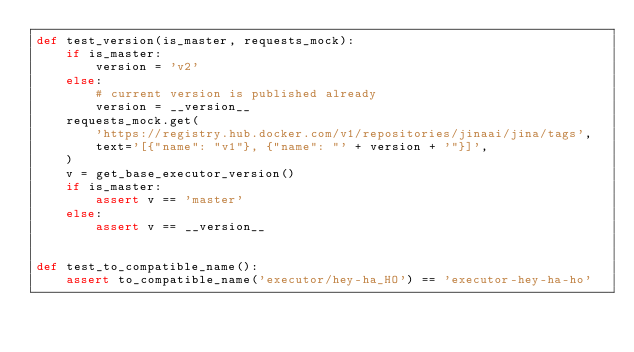Convert code to text. <code><loc_0><loc_0><loc_500><loc_500><_Python_>def test_version(is_master, requests_mock):
    if is_master:
        version = 'v2'
    else:
        # current version is published already
        version = __version__
    requests_mock.get(
        'https://registry.hub.docker.com/v1/repositories/jinaai/jina/tags',
        text='[{"name": "v1"}, {"name": "' + version + '"}]',
    )
    v = get_base_executor_version()
    if is_master:
        assert v == 'master'
    else:
        assert v == __version__


def test_to_compatible_name():
    assert to_compatible_name('executor/hey-ha_HO') == 'executor-hey-ha-ho'
</code> 